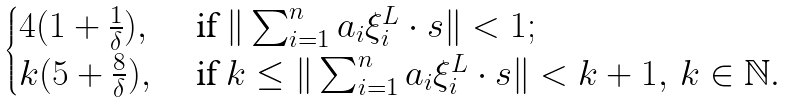Convert formula to latex. <formula><loc_0><loc_0><loc_500><loc_500>\begin{cases} 4 ( 1 + \frac { 1 } { \delta } ) , & \text { if } \| \sum _ { i = 1 } ^ { n } a _ { i } { \xi } _ { i } ^ { L } \cdot s \| < 1 ; \\ k ( 5 + \frac { 8 } { \delta } ) , & \text { if } k \leq \| \sum _ { i = 1 } ^ { n } a _ { i } { \xi } _ { i } ^ { L } \cdot s \| < k + 1 , \, k \in \mathbb { N } . \end{cases}</formula> 